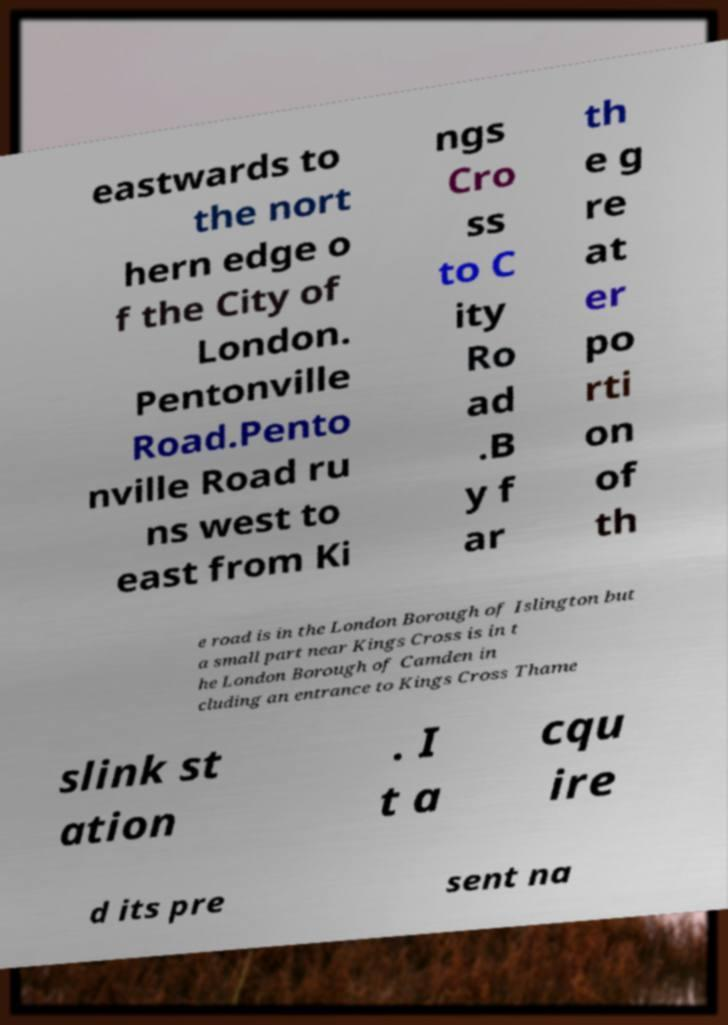For documentation purposes, I need the text within this image transcribed. Could you provide that? eastwards to the nort hern edge o f the City of London. Pentonville Road.Pento nville Road ru ns west to east from Ki ngs Cro ss to C ity Ro ad .B y f ar th e g re at er po rti on of th e road is in the London Borough of Islington but a small part near Kings Cross is in t he London Borough of Camden in cluding an entrance to Kings Cross Thame slink st ation . I t a cqu ire d its pre sent na 